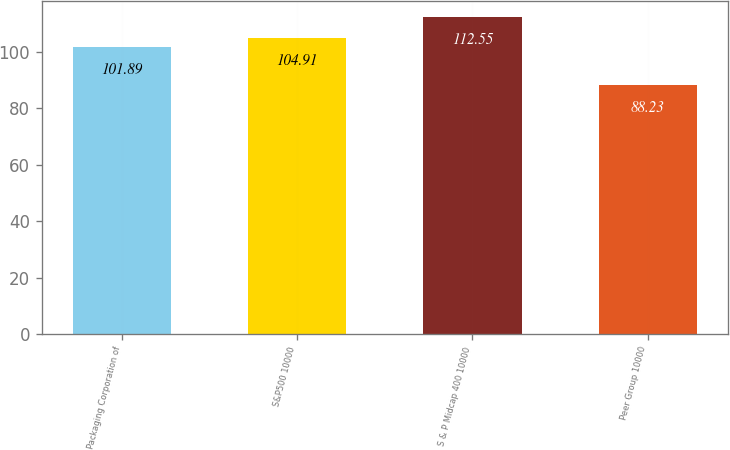Convert chart. <chart><loc_0><loc_0><loc_500><loc_500><bar_chart><fcel>Packaging Corporation of<fcel>S&P500 10000<fcel>S & P Midcap 400 10000<fcel>Peer Group 10000<nl><fcel>101.89<fcel>104.91<fcel>112.55<fcel>88.23<nl></chart> 